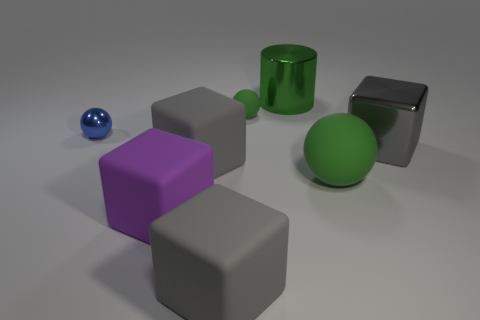Add 1 big green matte things. How many objects exist? 9 Subtract all blue spheres. How many spheres are left? 2 Subtract all metallic blocks. How many blocks are left? 3 Subtract 0 yellow cylinders. How many objects are left? 8 Subtract all cylinders. How many objects are left? 7 Subtract 1 cylinders. How many cylinders are left? 0 Subtract all brown spheres. Subtract all purple cubes. How many spheres are left? 3 Subtract all yellow cylinders. How many red blocks are left? 0 Subtract all large purple cubes. Subtract all balls. How many objects are left? 4 Add 8 big rubber spheres. How many big rubber spheres are left? 9 